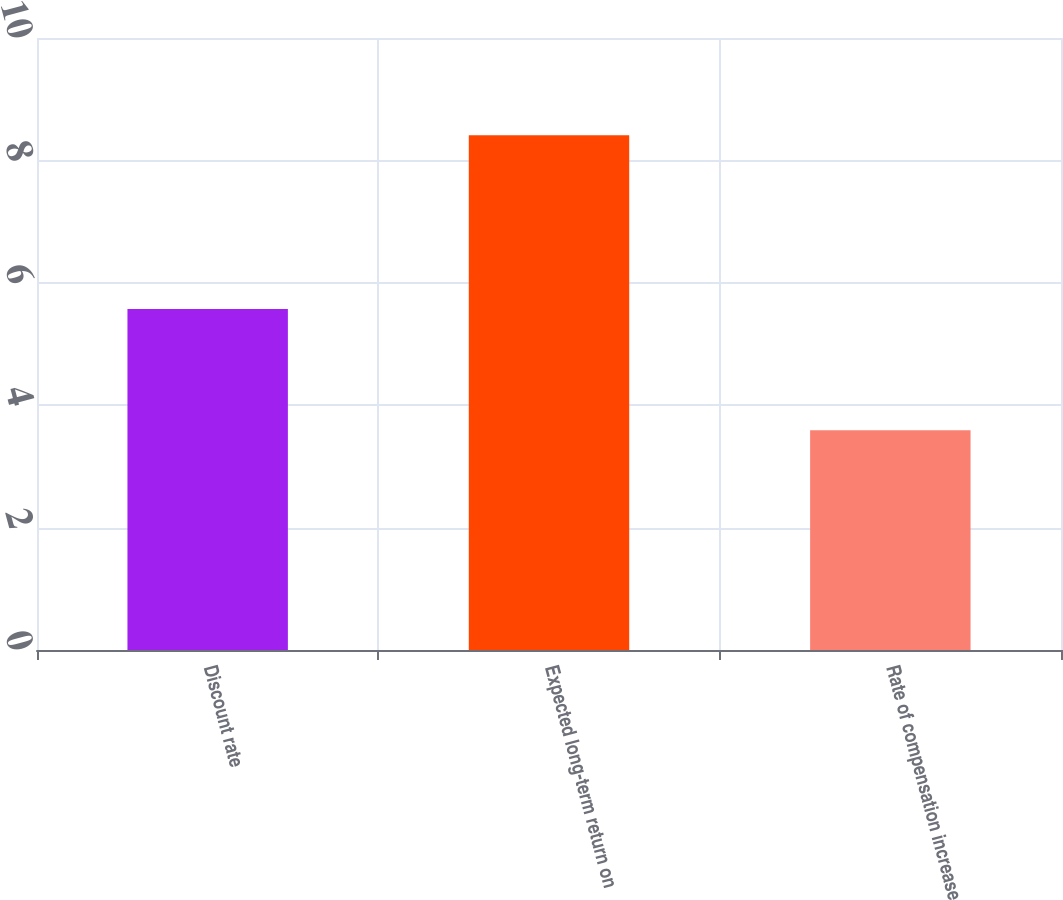Convert chart. <chart><loc_0><loc_0><loc_500><loc_500><bar_chart><fcel>Discount rate<fcel>Expected long-term return on<fcel>Rate of compensation increase<nl><fcel>5.57<fcel>8.41<fcel>3.59<nl></chart> 